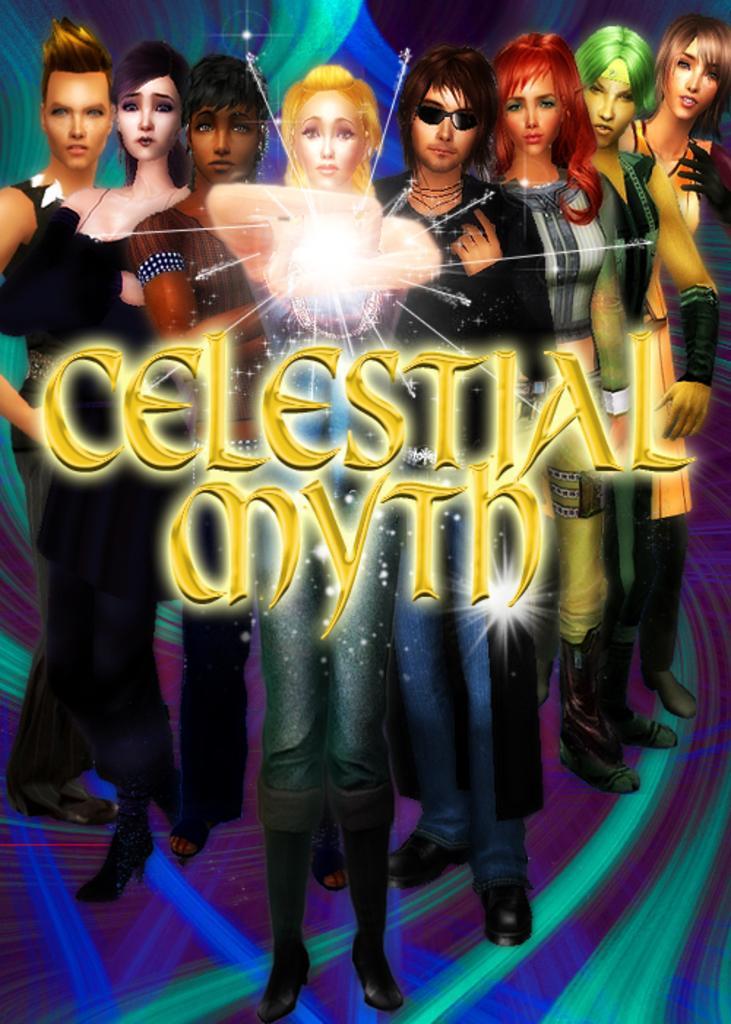Describe this image in one or two sentences. In this image there are eight animated characters and something is written in the middle, it say celestial myth. 